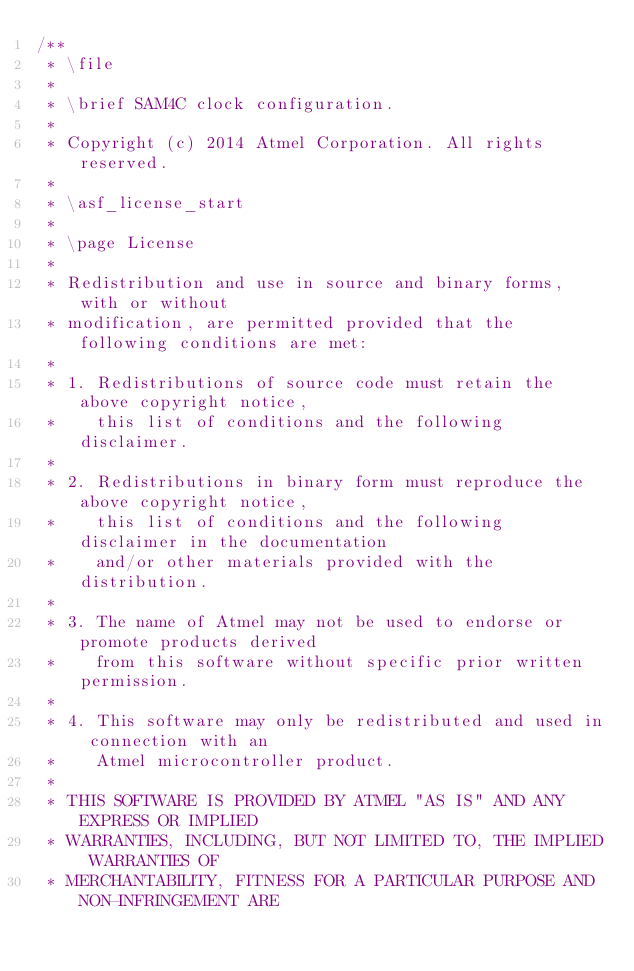Convert code to text. <code><loc_0><loc_0><loc_500><loc_500><_C_>/**
 * \file
 *
 * \brief SAM4C clock configuration.
 *
 * Copyright (c) 2014 Atmel Corporation. All rights reserved.
 *
 * \asf_license_start
 *
 * \page License
 *
 * Redistribution and use in source and binary forms, with or without
 * modification, are permitted provided that the following conditions are met:
 *
 * 1. Redistributions of source code must retain the above copyright notice,
 *    this list of conditions and the following disclaimer.
 *
 * 2. Redistributions in binary form must reproduce the above copyright notice,
 *    this list of conditions and the following disclaimer in the documentation
 *    and/or other materials provided with the distribution.
 *
 * 3. The name of Atmel may not be used to endorse or promote products derived
 *    from this software without specific prior written permission.
 *
 * 4. This software may only be redistributed and used in connection with an
 *    Atmel microcontroller product.
 *
 * THIS SOFTWARE IS PROVIDED BY ATMEL "AS IS" AND ANY EXPRESS OR IMPLIED
 * WARRANTIES, INCLUDING, BUT NOT LIMITED TO, THE IMPLIED WARRANTIES OF
 * MERCHANTABILITY, FITNESS FOR A PARTICULAR PURPOSE AND NON-INFRINGEMENT ARE</code> 